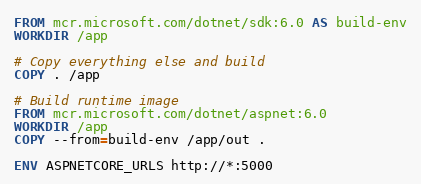<code> <loc_0><loc_0><loc_500><loc_500><_Dockerfile_>FROM mcr.microsoft.com/dotnet/sdk:6.0 AS build-env
WORKDIR /app

# Copy everything else and build
COPY . /app

# Build runtime image
FROM mcr.microsoft.com/dotnet/aspnet:6.0
WORKDIR /app
COPY --from=build-env /app/out .

ENV ASPNETCORE_URLS http://*:5000
</code> 